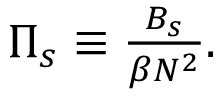Convert formula to latex. <formula><loc_0><loc_0><loc_500><loc_500>\begin{array} { r } { \Pi _ { s } \equiv \frac { B _ { s } } { \beta N ^ { 2 } } . } \end{array}</formula> 